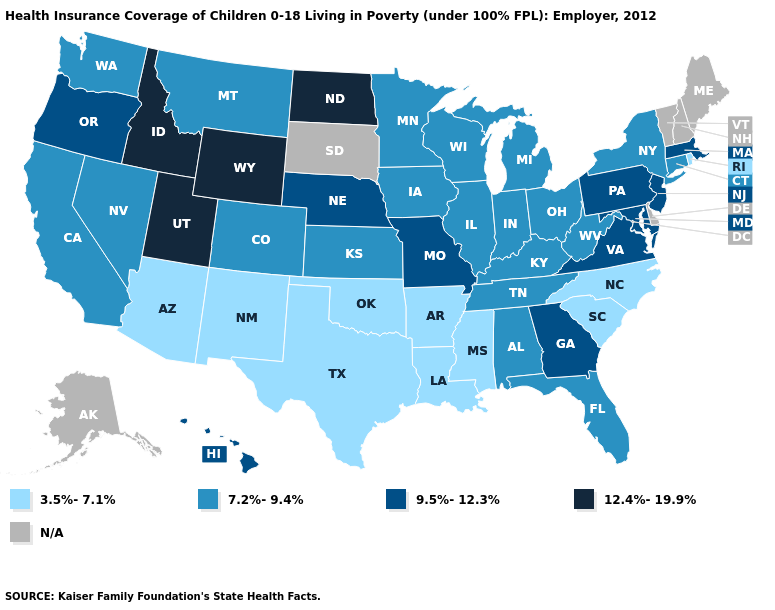What is the value of Alaska?
Give a very brief answer. N/A. How many symbols are there in the legend?
Give a very brief answer. 5. Name the states that have a value in the range 12.4%-19.9%?
Concise answer only. Idaho, North Dakota, Utah, Wyoming. Name the states that have a value in the range N/A?
Keep it brief. Alaska, Delaware, Maine, New Hampshire, South Dakota, Vermont. Name the states that have a value in the range 7.2%-9.4%?
Keep it brief. Alabama, California, Colorado, Connecticut, Florida, Illinois, Indiana, Iowa, Kansas, Kentucky, Michigan, Minnesota, Montana, Nevada, New York, Ohio, Tennessee, Washington, West Virginia, Wisconsin. What is the highest value in the West ?
Be succinct. 12.4%-19.9%. Does the first symbol in the legend represent the smallest category?
Be succinct. Yes. Does Kansas have the lowest value in the USA?
Quick response, please. No. Among the states that border Oregon , which have the lowest value?
Give a very brief answer. California, Nevada, Washington. What is the value of Connecticut?
Keep it brief. 7.2%-9.4%. Does the map have missing data?
Give a very brief answer. Yes. Which states have the lowest value in the USA?
Short answer required. Arizona, Arkansas, Louisiana, Mississippi, New Mexico, North Carolina, Oklahoma, Rhode Island, South Carolina, Texas. What is the value of Ohio?
Write a very short answer. 7.2%-9.4%. Does Idaho have the highest value in the USA?
Concise answer only. Yes. Is the legend a continuous bar?
Concise answer only. No. 